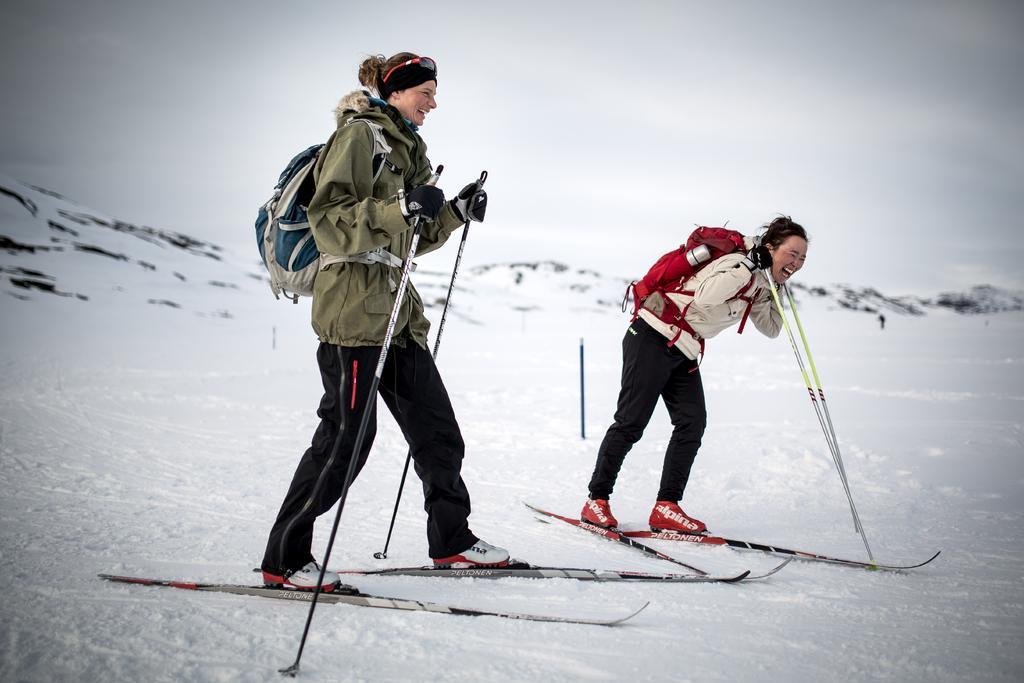In one or two sentences, can you explain what this image depicts? In this picture we can see two people carrying bags, standing on skis, holding sticks with their hands and smiling. In the background we can see a pole, snow, mountains and the sky. 